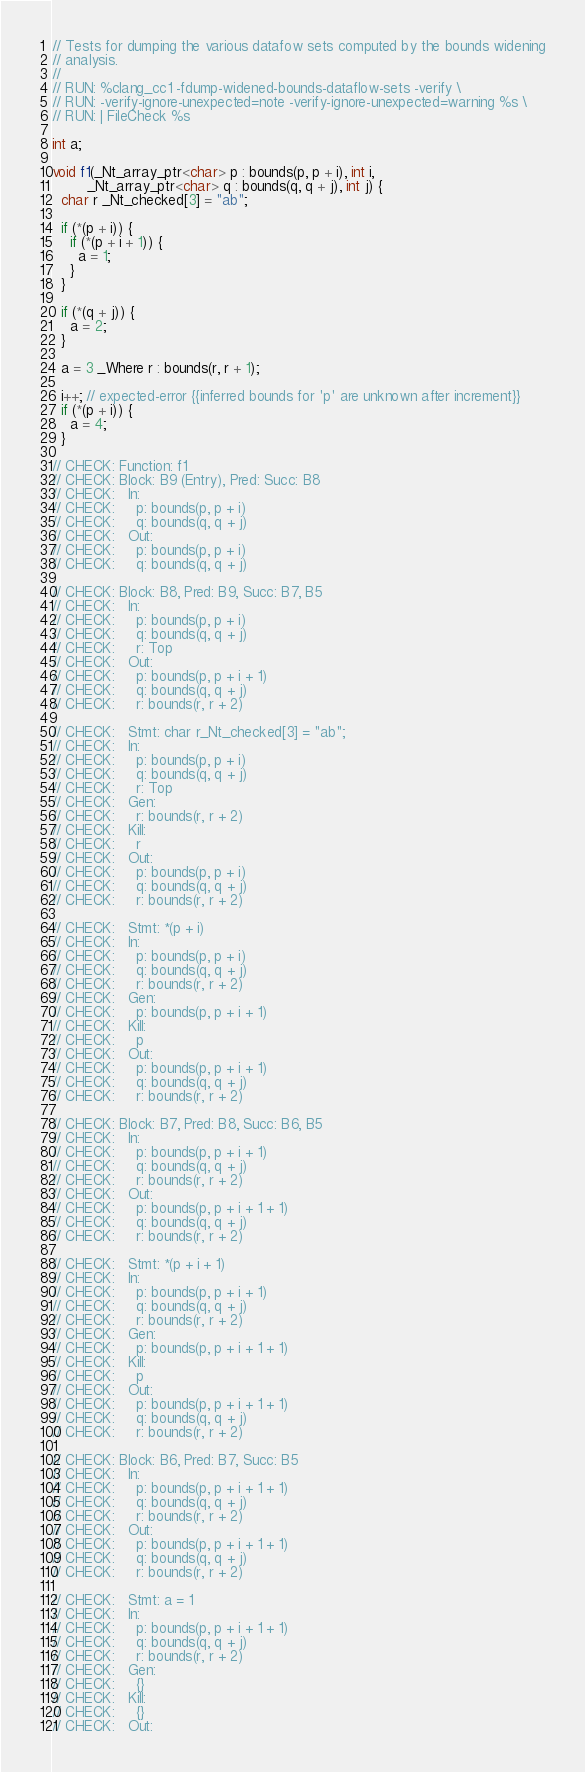<code> <loc_0><loc_0><loc_500><loc_500><_C_>// Tests for dumping the various datafow sets computed by the bounds widening
// analysis.
//
// RUN: %clang_cc1 -fdump-widened-bounds-dataflow-sets -verify \
// RUN: -verify-ignore-unexpected=note -verify-ignore-unexpected=warning %s \
// RUN: | FileCheck %s

int a;

void f1(_Nt_array_ptr<char> p : bounds(p, p + i), int i,
        _Nt_array_ptr<char> q : bounds(q, q + j), int j) {
  char r _Nt_checked[3] = "ab";

  if (*(p + i)) {
    if (*(p + i + 1)) {
      a = 1;
    }
  }

  if (*(q + j)) {
    a = 2;
  }

  a = 3 _Where r : bounds(r, r + 1);

  i++; // expected-error {{inferred bounds for 'p' are unknown after increment}}
  if (*(p + i)) {
    a = 4;
  }

// CHECK: Function: f1
// CHECK: Block: B9 (Entry), Pred: Succ: B8
// CHECK:   In:
// CHECK:     p: bounds(p, p + i)
// CHECK:     q: bounds(q, q + j)
// CHECK:   Out:
// CHECK:     p: bounds(p, p + i)
// CHECK:     q: bounds(q, q + j)

// CHECK: Block: B8, Pred: B9, Succ: B7, B5
// CHECK:   In:
// CHECK:     p: bounds(p, p + i)
// CHECK:     q: bounds(q, q + j)
// CHECK:     r: Top
// CHECK:   Out:
// CHECK:     p: bounds(p, p + i + 1)
// CHECK:     q: bounds(q, q + j)
// CHECK:     r: bounds(r, r + 2)

// CHECK:   Stmt: char r_Nt_checked[3] = "ab";
// CHECK:   In:
// CHECK:     p: bounds(p, p + i)
// CHECK:     q: bounds(q, q + j)
// CHECK:     r: Top
// CHECK:   Gen:
// CHECK:     r: bounds(r, r + 2)
// CHECK:   Kill:
// CHECK:     r
// CHECK:   Out:
// CHECK:     p: bounds(p, p + i)
// CHECK:     q: bounds(q, q + j)
// CHECK:     r: bounds(r, r + 2)

// CHECK:   Stmt: *(p + i)
// CHECK:   In:
// CHECK:     p: bounds(p, p + i)
// CHECK:     q: bounds(q, q + j)
// CHECK:     r: bounds(r, r + 2)
// CHECK:   Gen:
// CHECK:     p: bounds(p, p + i + 1)
// CHECK:   Kill:
// CHECK:     p
// CHECK:   Out:
// CHECK:     p: bounds(p, p + i + 1)
// CHECK:     q: bounds(q, q + j)
// CHECK:     r: bounds(r, r + 2)

// CHECK: Block: B7, Pred: B8, Succ: B6, B5
// CHECK:   In:
// CHECK:     p: bounds(p, p + i + 1)
// CHECK:     q: bounds(q, q + j)
// CHECK:     r: bounds(r, r + 2)
// CHECK:   Out:
// CHECK:     p: bounds(p, p + i + 1 + 1)
// CHECK:     q: bounds(q, q + j)
// CHECK:     r: bounds(r, r + 2)

// CHECK:   Stmt: *(p + i + 1)
// CHECK:   In:
// CHECK:     p: bounds(p, p + i + 1)
// CHECK:     q: bounds(q, q + j)
// CHECK:     r: bounds(r, r + 2)
// CHECK:   Gen:
// CHECK:     p: bounds(p, p + i + 1 + 1)
// CHECK:   Kill:
// CHECK:     p
// CHECK:   Out:
// CHECK:     p: bounds(p, p + i + 1 + 1)
// CHECK:     q: bounds(q, q + j)
// CHECK:     r: bounds(r, r + 2)

// CHECK: Block: B6, Pred: B7, Succ: B5
// CHECK:   In:
// CHECK:     p: bounds(p, p + i + 1 + 1)
// CHECK:     q: bounds(q, q + j)
// CHECK:     r: bounds(r, r + 2)
// CHECK:   Out:
// CHECK:     p: bounds(p, p + i + 1 + 1)
// CHECK:     q: bounds(q, q + j)
// CHECK:     r: bounds(r, r + 2)

// CHECK:   Stmt: a = 1
// CHECK:   In:
// CHECK:     p: bounds(p, p + i + 1 + 1)
// CHECK:     q: bounds(q, q + j)
// CHECK:     r: bounds(r, r + 2)
// CHECK:   Gen:
// CHECK:     {}
// CHECK:   Kill:
// CHECK:     {}
// CHECK:   Out:</code> 